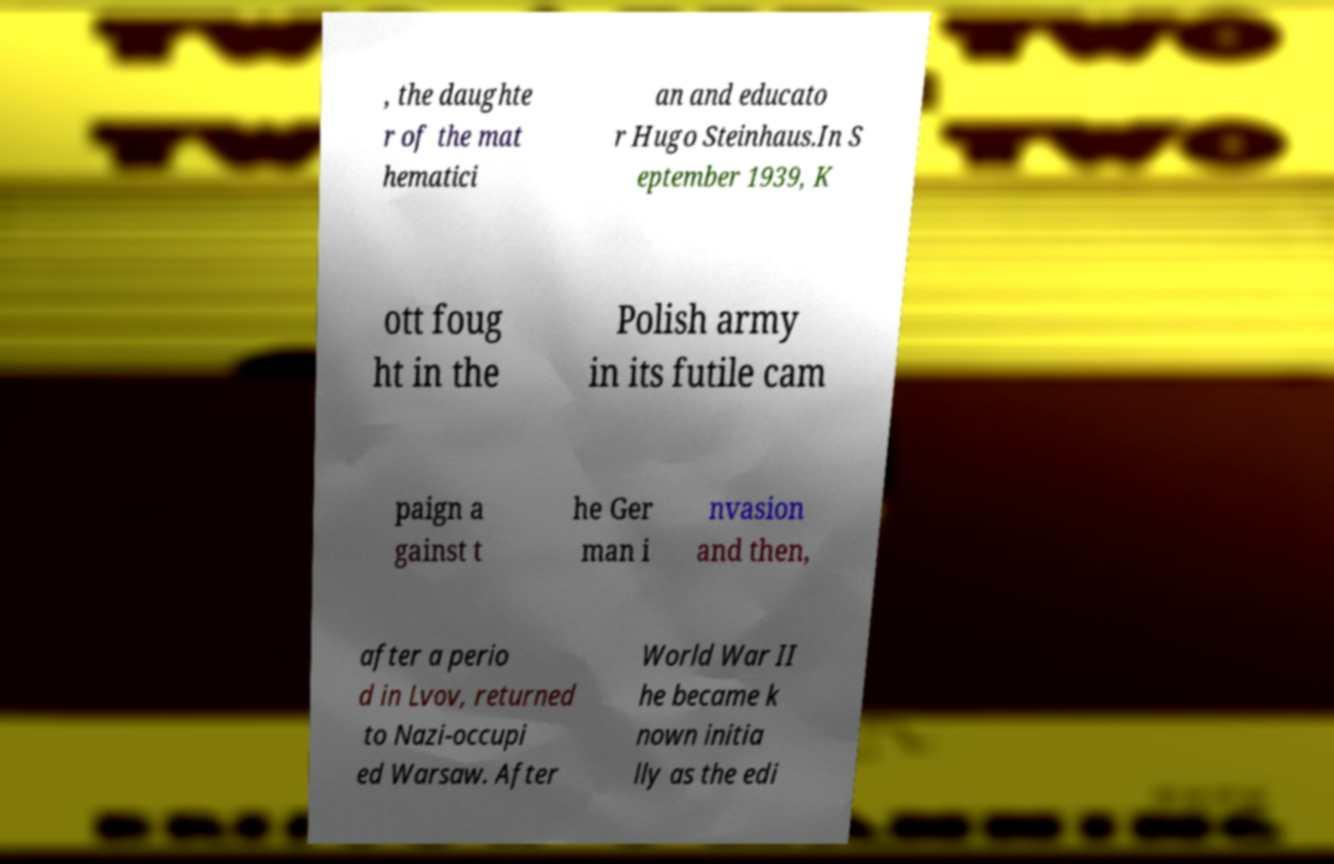Could you assist in decoding the text presented in this image and type it out clearly? , the daughte r of the mat hematici an and educato r Hugo Steinhaus.In S eptember 1939, K ott foug ht in the Polish army in its futile cam paign a gainst t he Ger man i nvasion and then, after a perio d in Lvov, returned to Nazi-occupi ed Warsaw. After World War II he became k nown initia lly as the edi 